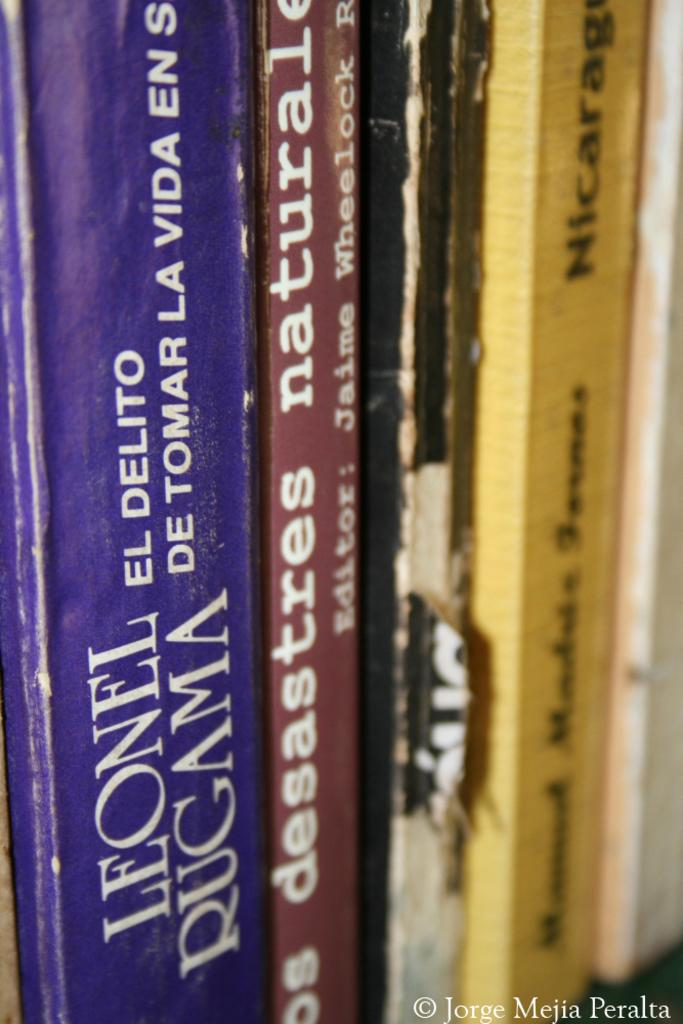<image>
Summarize the visual content of the image. A collection of books including one written by Leonel Rugama. 